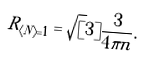<formula> <loc_0><loc_0><loc_500><loc_500>R _ { \langle N \rangle = 1 } = \sqrt { [ } 3 ] { \frac { 3 } { 4 \pi n } } .</formula> 